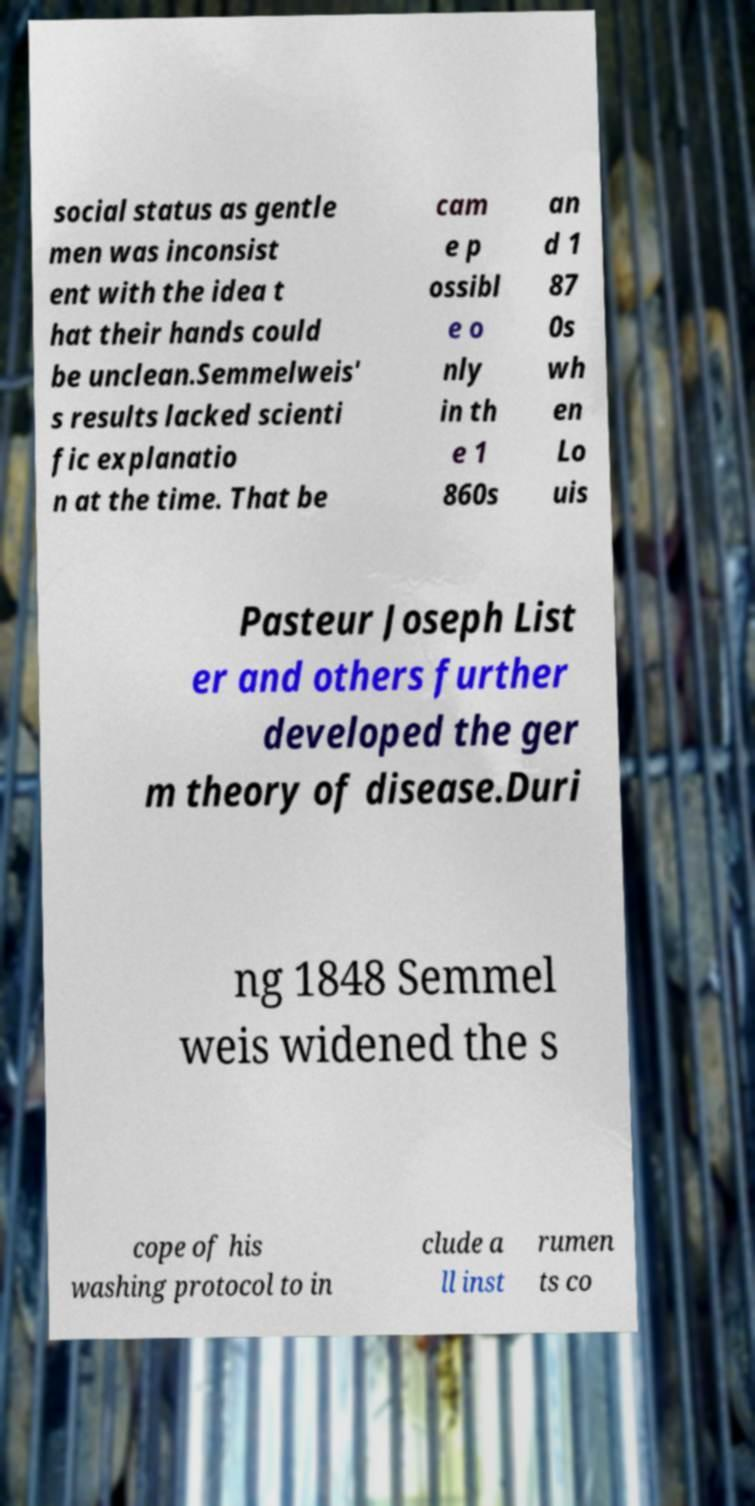Can you read and provide the text displayed in the image?This photo seems to have some interesting text. Can you extract and type it out for me? social status as gentle men was inconsist ent with the idea t hat their hands could be unclean.Semmelweis' s results lacked scienti fic explanatio n at the time. That be cam e p ossibl e o nly in th e 1 860s an d 1 87 0s wh en Lo uis Pasteur Joseph List er and others further developed the ger m theory of disease.Duri ng 1848 Semmel weis widened the s cope of his washing protocol to in clude a ll inst rumen ts co 